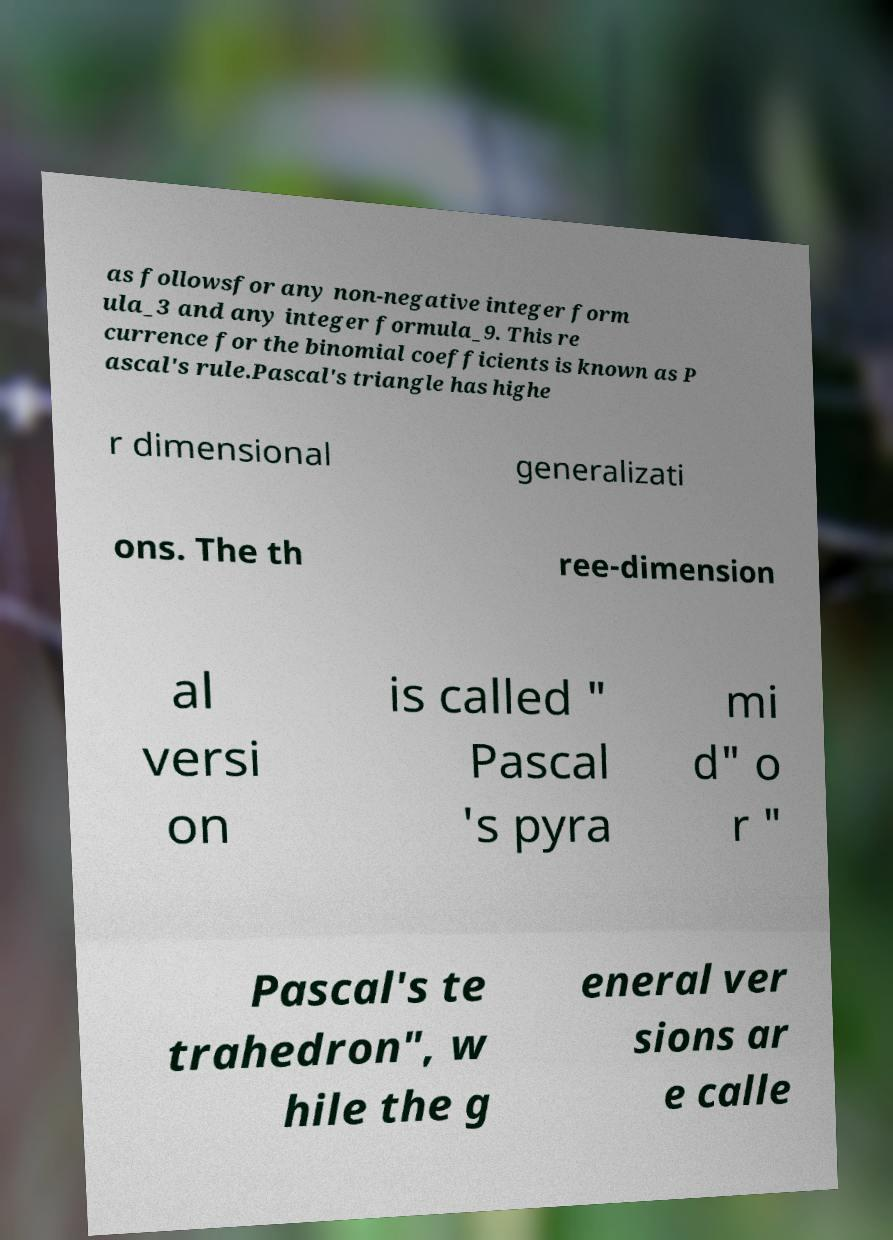There's text embedded in this image that I need extracted. Can you transcribe it verbatim? as followsfor any non-negative integer form ula_3 and any integer formula_9. This re currence for the binomial coefficients is known as P ascal's rule.Pascal's triangle has highe r dimensional generalizati ons. The th ree-dimension al versi on is called " Pascal 's pyra mi d" o r " Pascal's te trahedron", w hile the g eneral ver sions ar e calle 